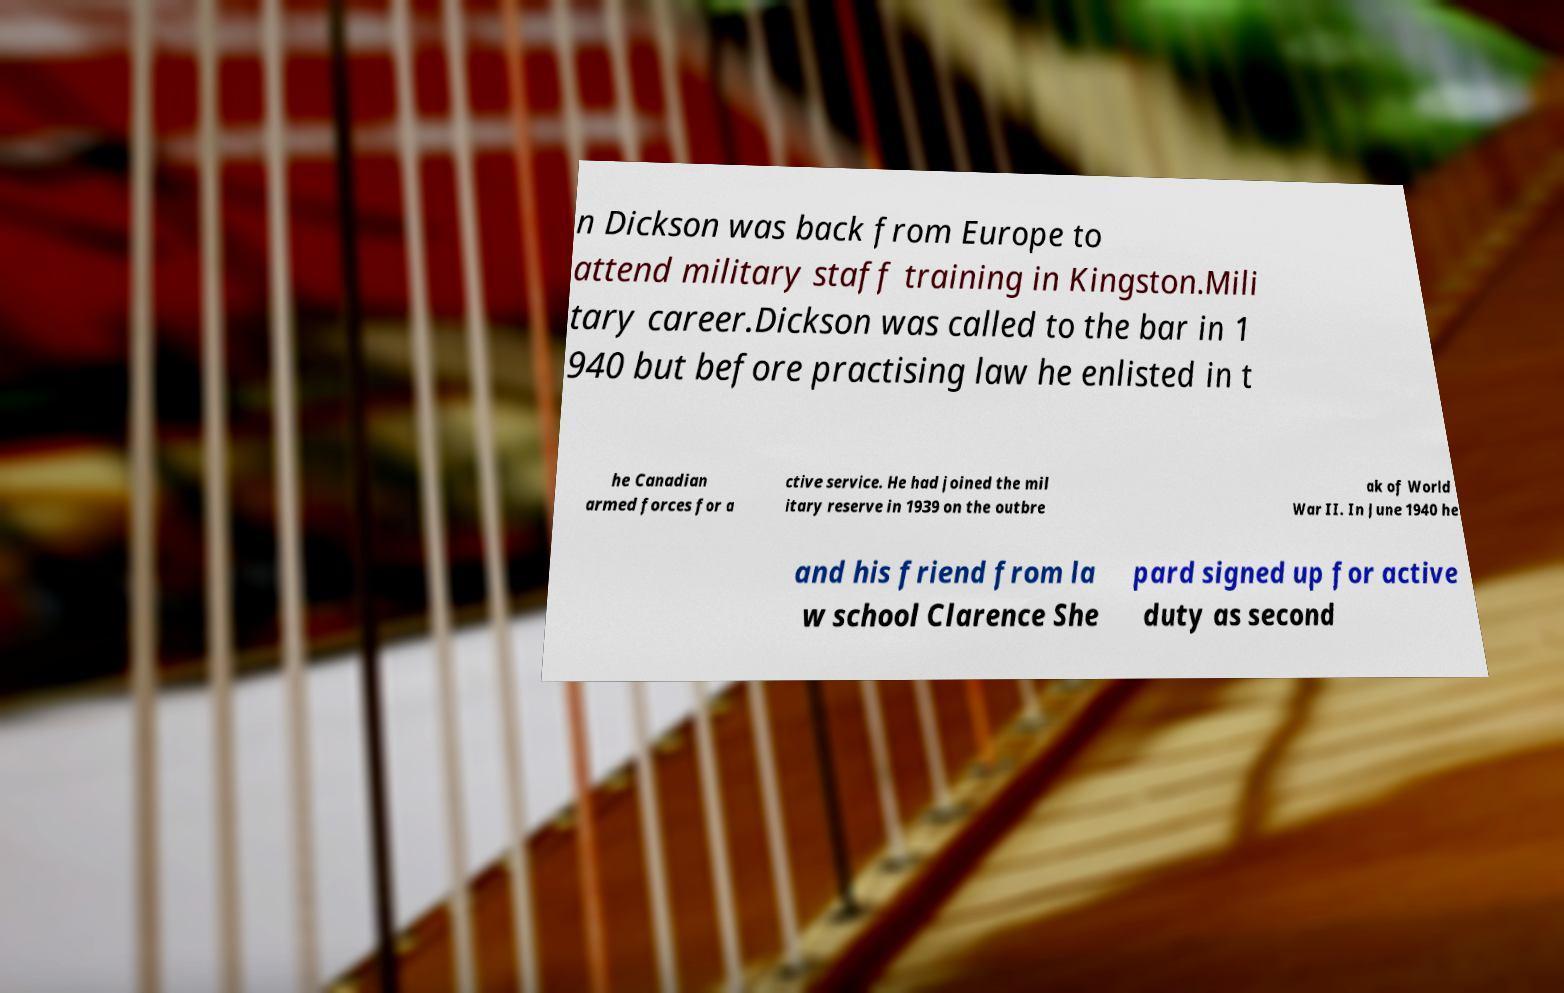What messages or text are displayed in this image? I need them in a readable, typed format. n Dickson was back from Europe to attend military staff training in Kingston.Mili tary career.Dickson was called to the bar in 1 940 but before practising law he enlisted in t he Canadian armed forces for a ctive service. He had joined the mil itary reserve in 1939 on the outbre ak of World War II. In June 1940 he and his friend from la w school Clarence She pard signed up for active duty as second 